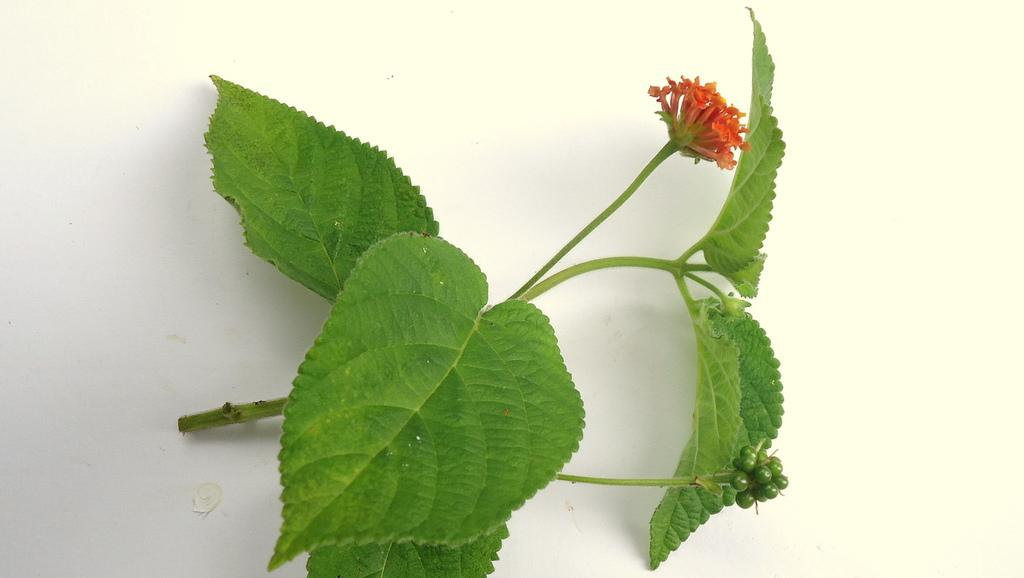What type of plant can be seen in the image? There is a flower in the image. Are there any other parts of the plant visible in the image? Yes, there are leaves in the image. What type of bean is being used as a prop in the image? There is no bean present in the image; it features a flower and leaves. What type of joke is being told by the flower in the image? There is no joke being told in the image; it simply shows a flower and leaves. 